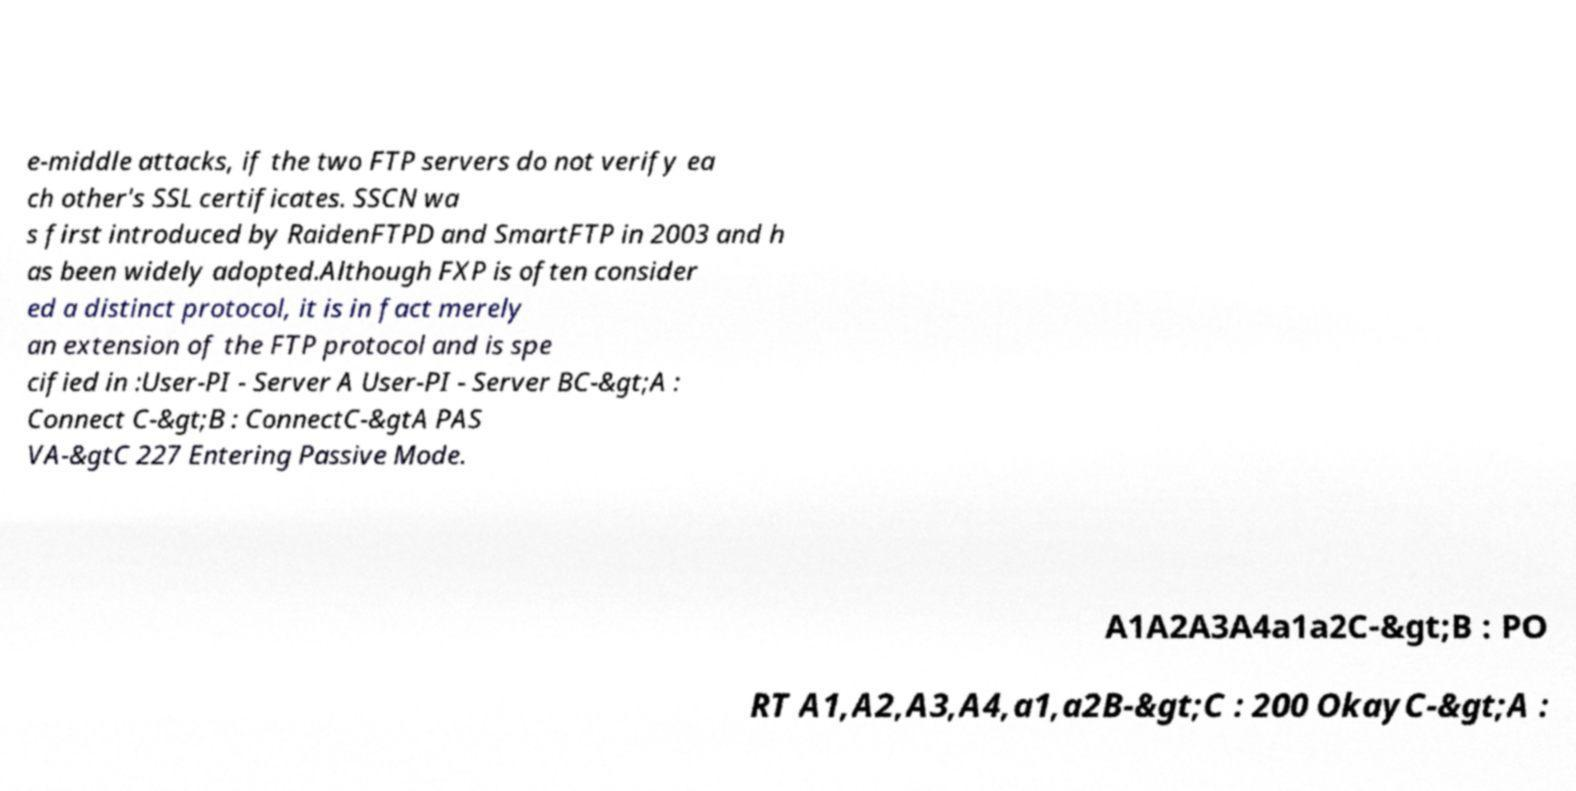Can you read and provide the text displayed in the image?This photo seems to have some interesting text. Can you extract and type it out for me? e-middle attacks, if the two FTP servers do not verify ea ch other's SSL certificates. SSCN wa s first introduced by RaidenFTPD and SmartFTP in 2003 and h as been widely adopted.Although FXP is often consider ed a distinct protocol, it is in fact merely an extension of the FTP protocol and is spe cified in :User-PI - Server A User-PI - Server BC-&gt;A : Connect C-&gt;B : ConnectC-&gtA PAS VA-&gtC 227 Entering Passive Mode. A1A2A3A4a1a2C-&gt;B : PO RT A1,A2,A3,A4,a1,a2B-&gt;C : 200 OkayC-&gt;A : 